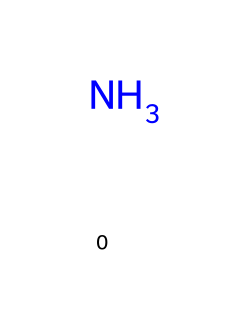What is the molecular formula of ammonia? The molecular formula is determined by counting the number of nitrogen and hydrogen atoms in the structure. Ammonia consists of one nitrogen atom (N) and three hydrogen atoms (H), leading to the formula NH3.
Answer: NH3 How many hydrogen atoms are present in ammonia? The number of hydrogen atoms can be directly identified from the structure of ammonia where three hydrogen atoms are bonded to one nitrogen atom.
Answer: 3 Is ammonia a gas at room temperature? Ammonia is a known gas at room temperature and atmospheric pressure, which is a characteristic property of this compound.
Answer: Yes What type of bond is present in ammonia? The bonds in ammonia are covalent bonds, formed by the sharing of electrons between the nitrogen and hydrogen atoms.
Answer: Covalent What is a primary use of ammonia in industrial applications? Ammonia is primarily utilized as a refrigerant in industrial cooling systems due to its efficient heat absorption properties.
Answer: Refrigerant How does the structure of ammonia contribute to its role as a refrigerant? Ammonia's structure allows for effective heat exchange and high latent heat of vaporization, making it suitable for cooling applications.
Answer: Effective heat exchange Why is ammonia considered a natural refrigerant? Ammonia is considered natural because it occurs naturally in the environment, is not a synthetic compound, and has low global warming potential.
Answer: Low global warming potential 